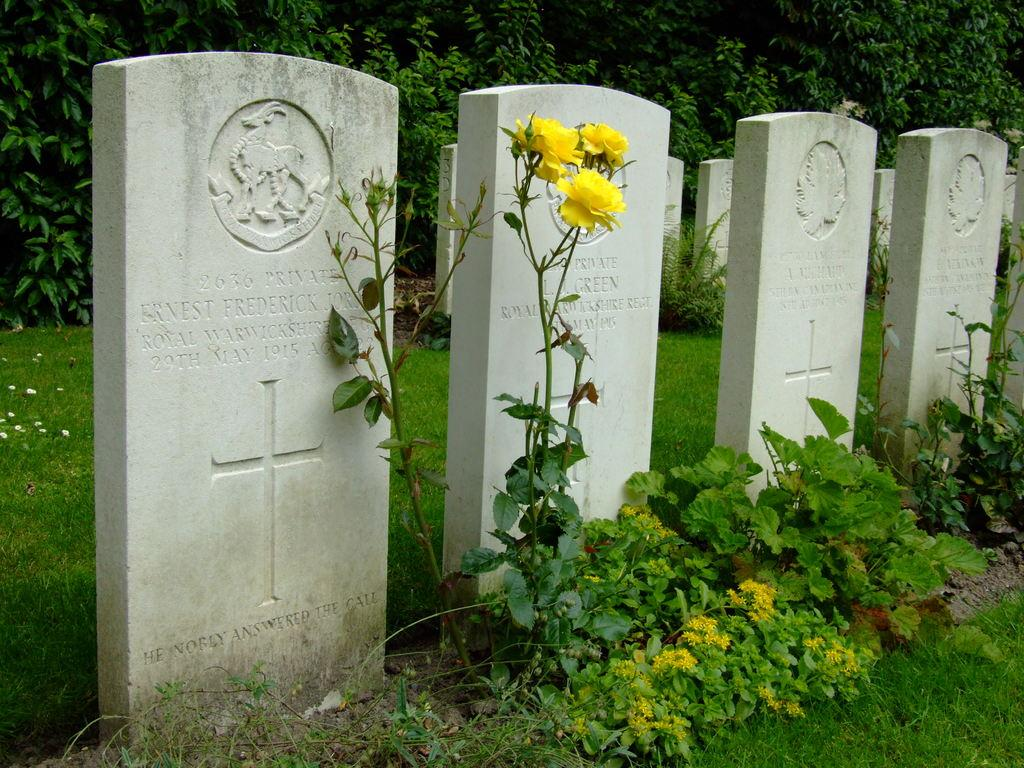What can be seen in the image that represents burial sites? There are graves in the image. How are the graves decorated or identified? The graves have text and design on them. What type of vegetation is present on the ground in the image? There is grass on the ground. What type of plants with flowers can be seen in the image? There are plants with flowers in the image. What can be seen in the background of the image? In the background, there are stems with leaves. Can you tell me how many cherries are on the farm in the image? There is no farm or cherries present in the image; it features graves with text and design, grass, plants with flowers, and stems with leaves in the background. What type of pig can be seen interacting with the graves in the image? There is no pig present in the image; it only features graves, grass, plants with flowers, and stems with leaves in the background. 